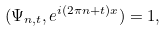Convert formula to latex. <formula><loc_0><loc_0><loc_500><loc_500>( \Psi _ { n , t } , e ^ { i ( 2 \pi n + t ) x } ) = 1 ,</formula> 